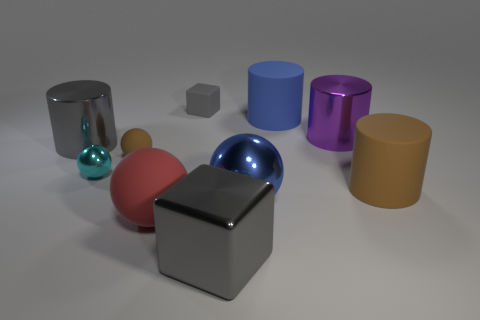There is a purple thing; is it the same size as the gray metal thing in front of the big blue metallic object?
Offer a terse response. Yes. How many small rubber spheres are there?
Provide a succinct answer. 1. There is a blue matte cylinder behind the big purple thing; is it the same size as the cylinder to the right of the purple cylinder?
Provide a succinct answer. Yes. The other big metallic object that is the same shape as the red thing is what color?
Keep it short and to the point. Blue. Is the shape of the big blue matte thing the same as the blue shiny thing?
Ensure brevity in your answer.  No. There is a red rubber object that is the same shape as the tiny brown thing; what is its size?
Your answer should be compact. Large. What number of small cyan objects have the same material as the big purple cylinder?
Give a very brief answer. 1. What number of things are either tiny purple metal cylinders or big red matte things?
Provide a succinct answer. 1. Are there any large red matte balls behind the big metal cylinder that is to the left of the blue ball?
Offer a very short reply. No. Is the number of blue metal balls behind the blue rubber cylinder greater than the number of large objects to the left of the large brown cylinder?
Ensure brevity in your answer.  No. 